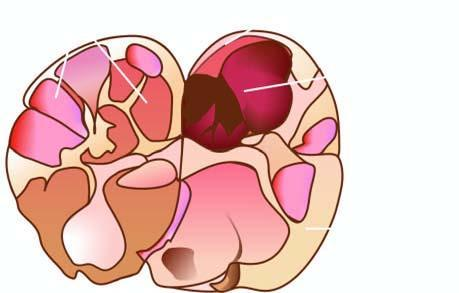does sectioned surface of the thyroid show a solitary nodule having capsule?
Answer the question using a single word or phrase. Yes 